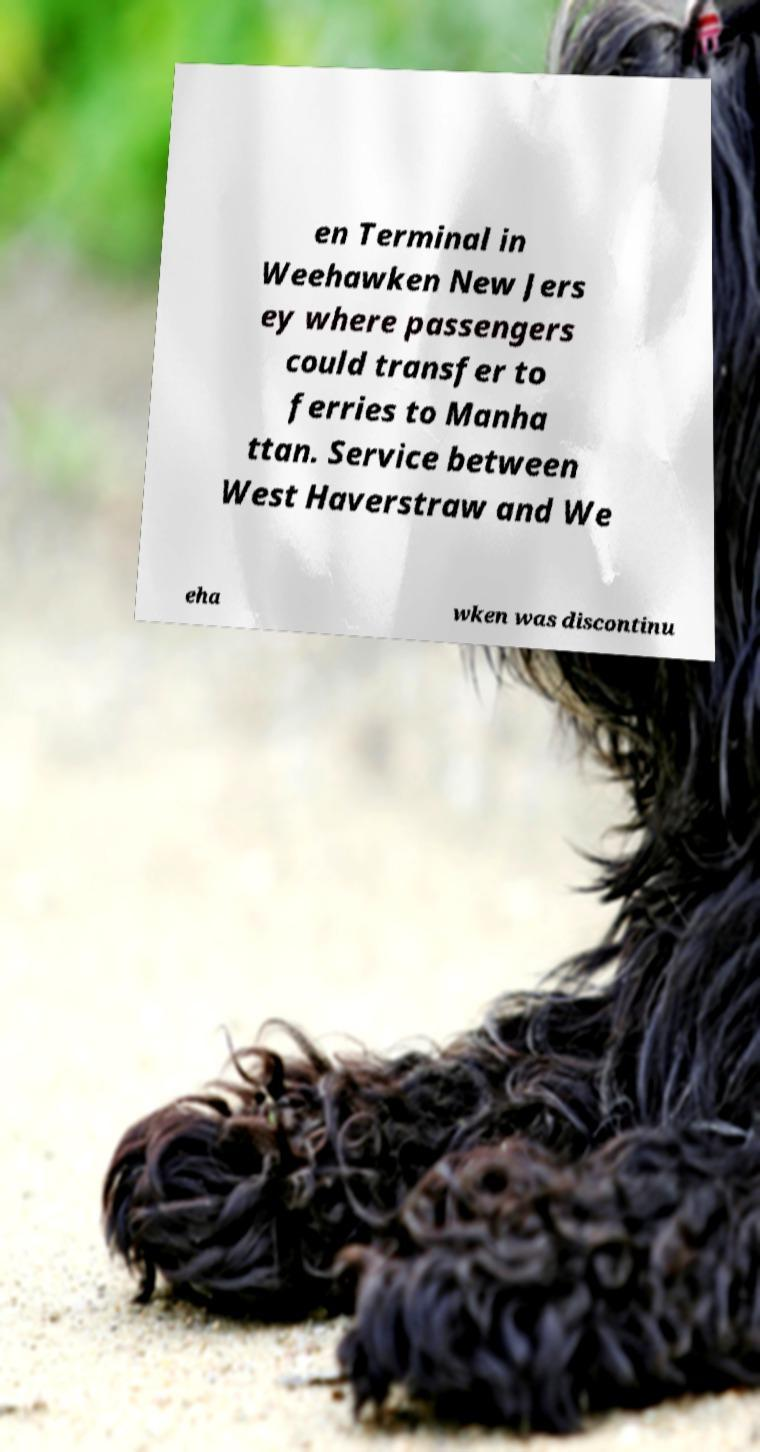Can you read and provide the text displayed in the image?This photo seems to have some interesting text. Can you extract and type it out for me? en Terminal in Weehawken New Jers ey where passengers could transfer to ferries to Manha ttan. Service between West Haverstraw and We eha wken was discontinu 